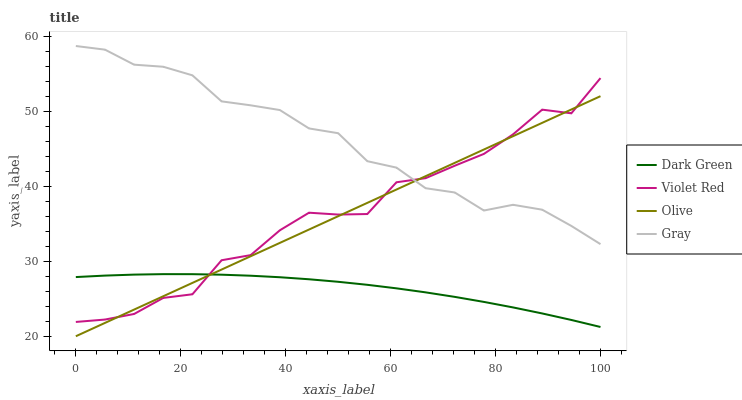Does Dark Green have the minimum area under the curve?
Answer yes or no. Yes. Does Gray have the maximum area under the curve?
Answer yes or no. Yes. Does Violet Red have the minimum area under the curve?
Answer yes or no. No. Does Violet Red have the maximum area under the curve?
Answer yes or no. No. Is Olive the smoothest?
Answer yes or no. Yes. Is Violet Red the roughest?
Answer yes or no. Yes. Is Gray the smoothest?
Answer yes or no. No. Is Gray the roughest?
Answer yes or no. No. Does Olive have the lowest value?
Answer yes or no. Yes. Does Violet Red have the lowest value?
Answer yes or no. No. Does Gray have the highest value?
Answer yes or no. Yes. Does Violet Red have the highest value?
Answer yes or no. No. Is Dark Green less than Gray?
Answer yes or no. Yes. Is Gray greater than Dark Green?
Answer yes or no. Yes. Does Olive intersect Gray?
Answer yes or no. Yes. Is Olive less than Gray?
Answer yes or no. No. Is Olive greater than Gray?
Answer yes or no. No. Does Dark Green intersect Gray?
Answer yes or no. No. 